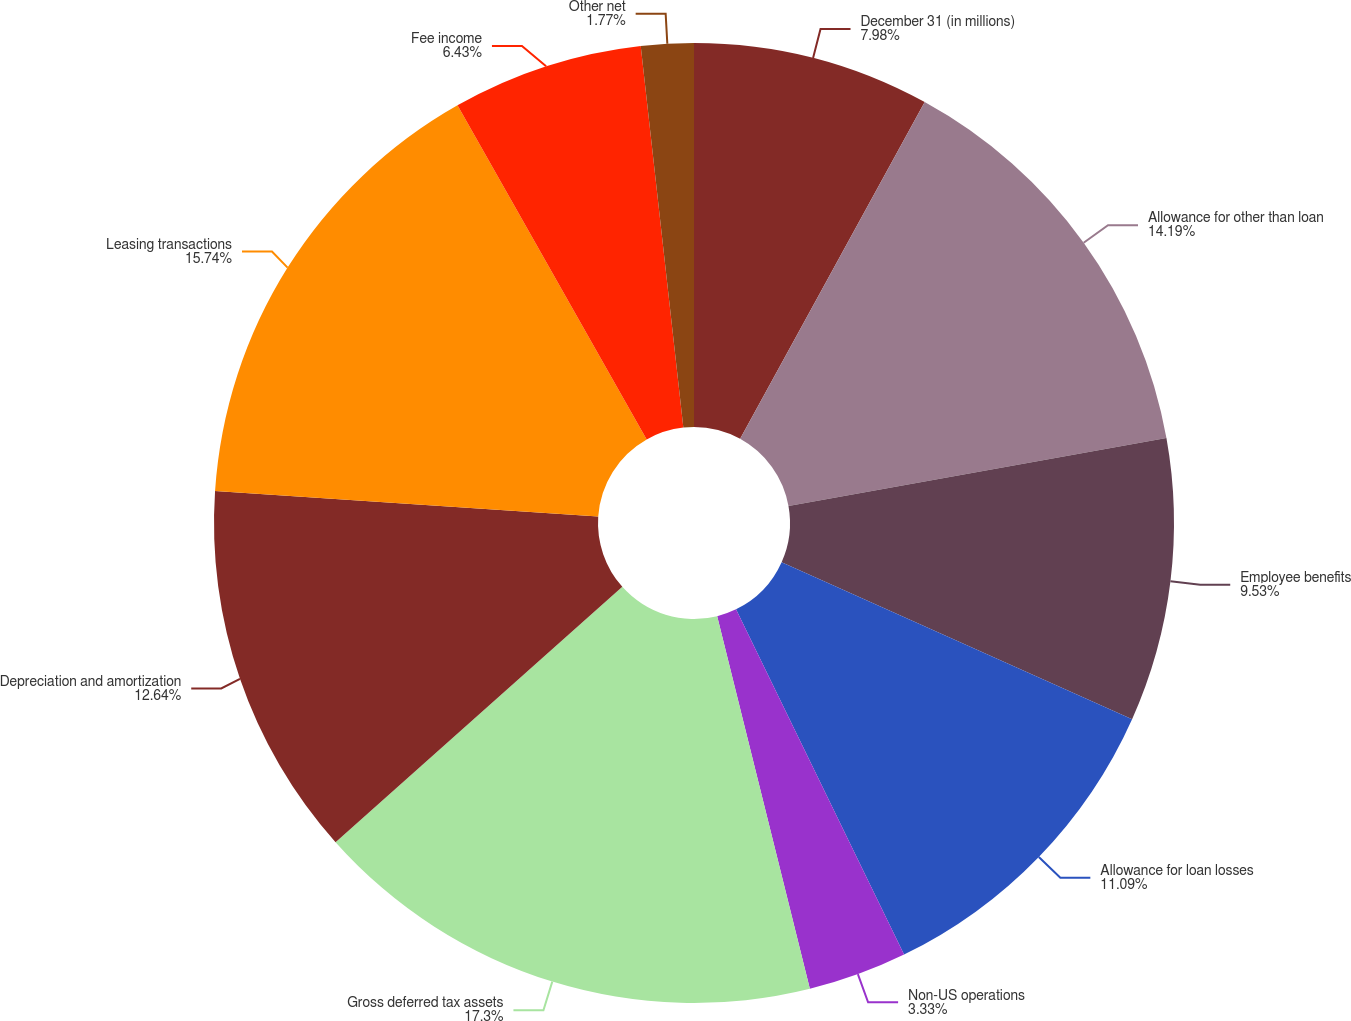Convert chart. <chart><loc_0><loc_0><loc_500><loc_500><pie_chart><fcel>December 31 (in millions)<fcel>Allowance for other than loan<fcel>Employee benefits<fcel>Allowance for loan losses<fcel>Non-US operations<fcel>Gross deferred tax assets<fcel>Depreciation and amortization<fcel>Leasing transactions<fcel>Fee income<fcel>Other net<nl><fcel>7.98%<fcel>14.19%<fcel>9.53%<fcel>11.09%<fcel>3.33%<fcel>17.3%<fcel>12.64%<fcel>15.74%<fcel>6.43%<fcel>1.77%<nl></chart> 